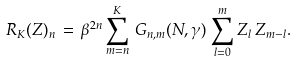Convert formula to latex. <formula><loc_0><loc_0><loc_500><loc_500>R _ { K } ( Z ) _ { n } \, = \, \beta ^ { 2 n } \sum _ { m = n } ^ { K } \, G _ { n , m } ( N , \gamma ) \, \sum _ { l = 0 } ^ { m } Z _ { l } \, Z _ { m - l } .</formula> 